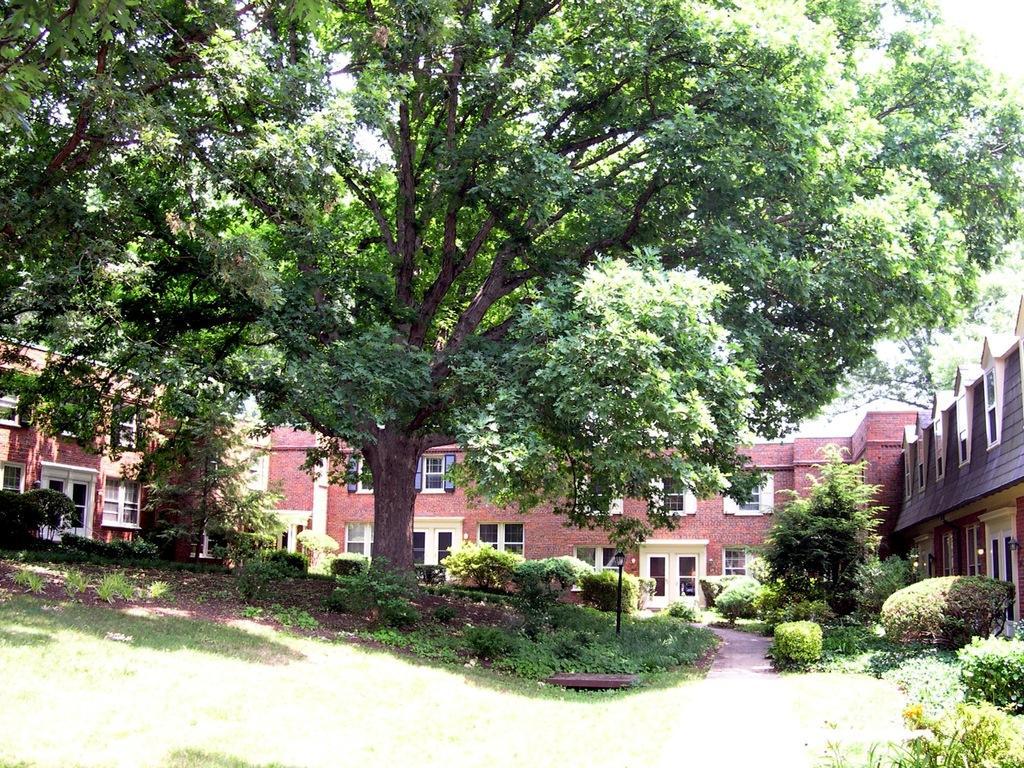Describe this image in one or two sentences. In this picture we can see the grass and plants on the ground and in the background we can see trees and a building. 